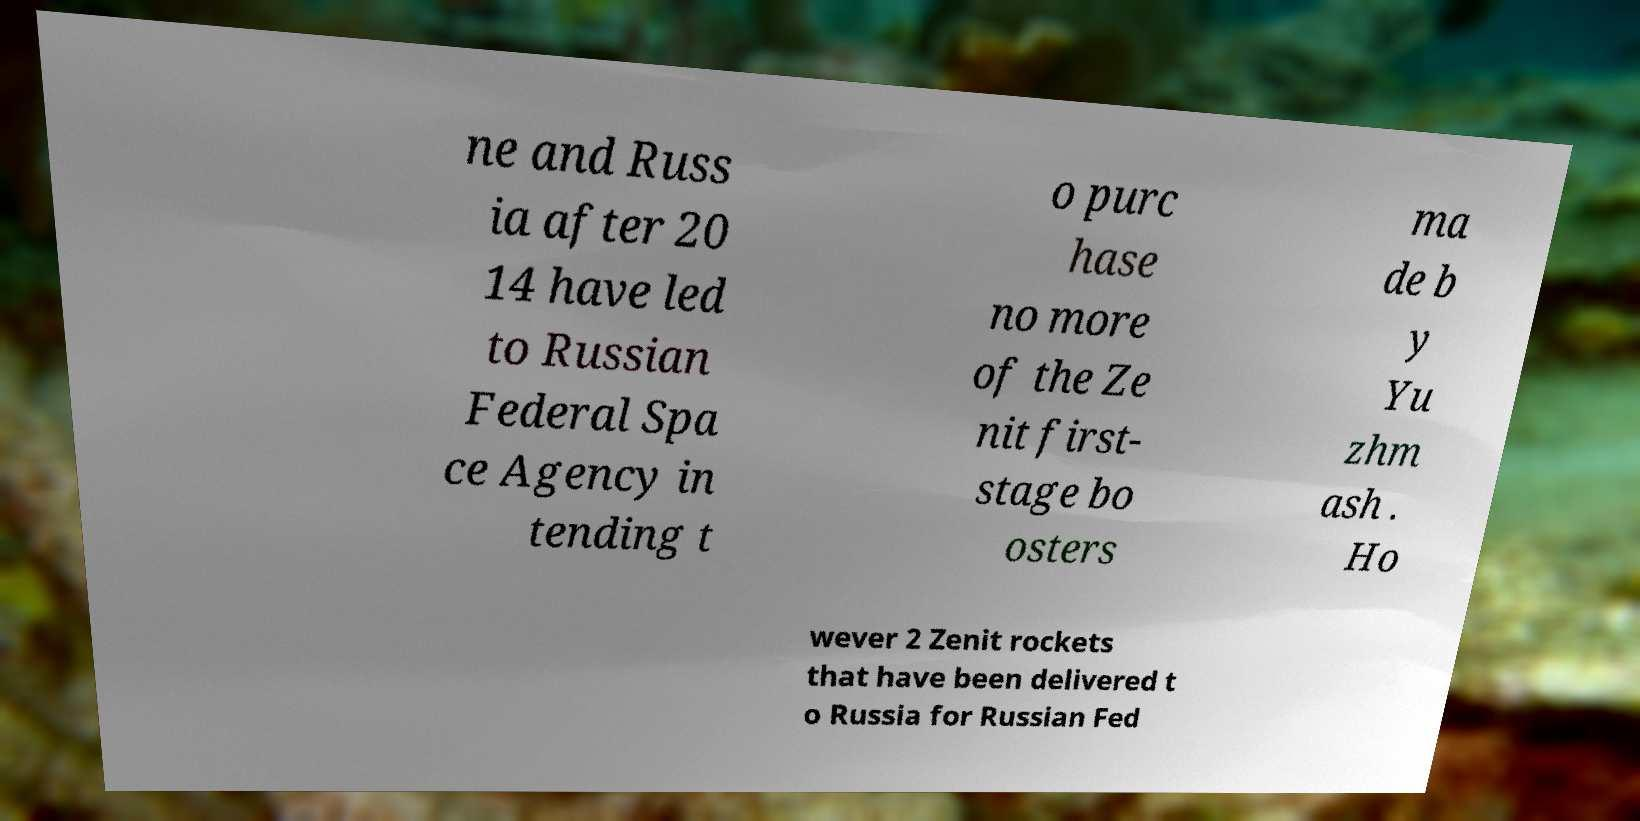I need the written content from this picture converted into text. Can you do that? ne and Russ ia after 20 14 have led to Russian Federal Spa ce Agency in tending t o purc hase no more of the Ze nit first- stage bo osters ma de b y Yu zhm ash . Ho wever 2 Zenit rockets that have been delivered t o Russia for Russian Fed 